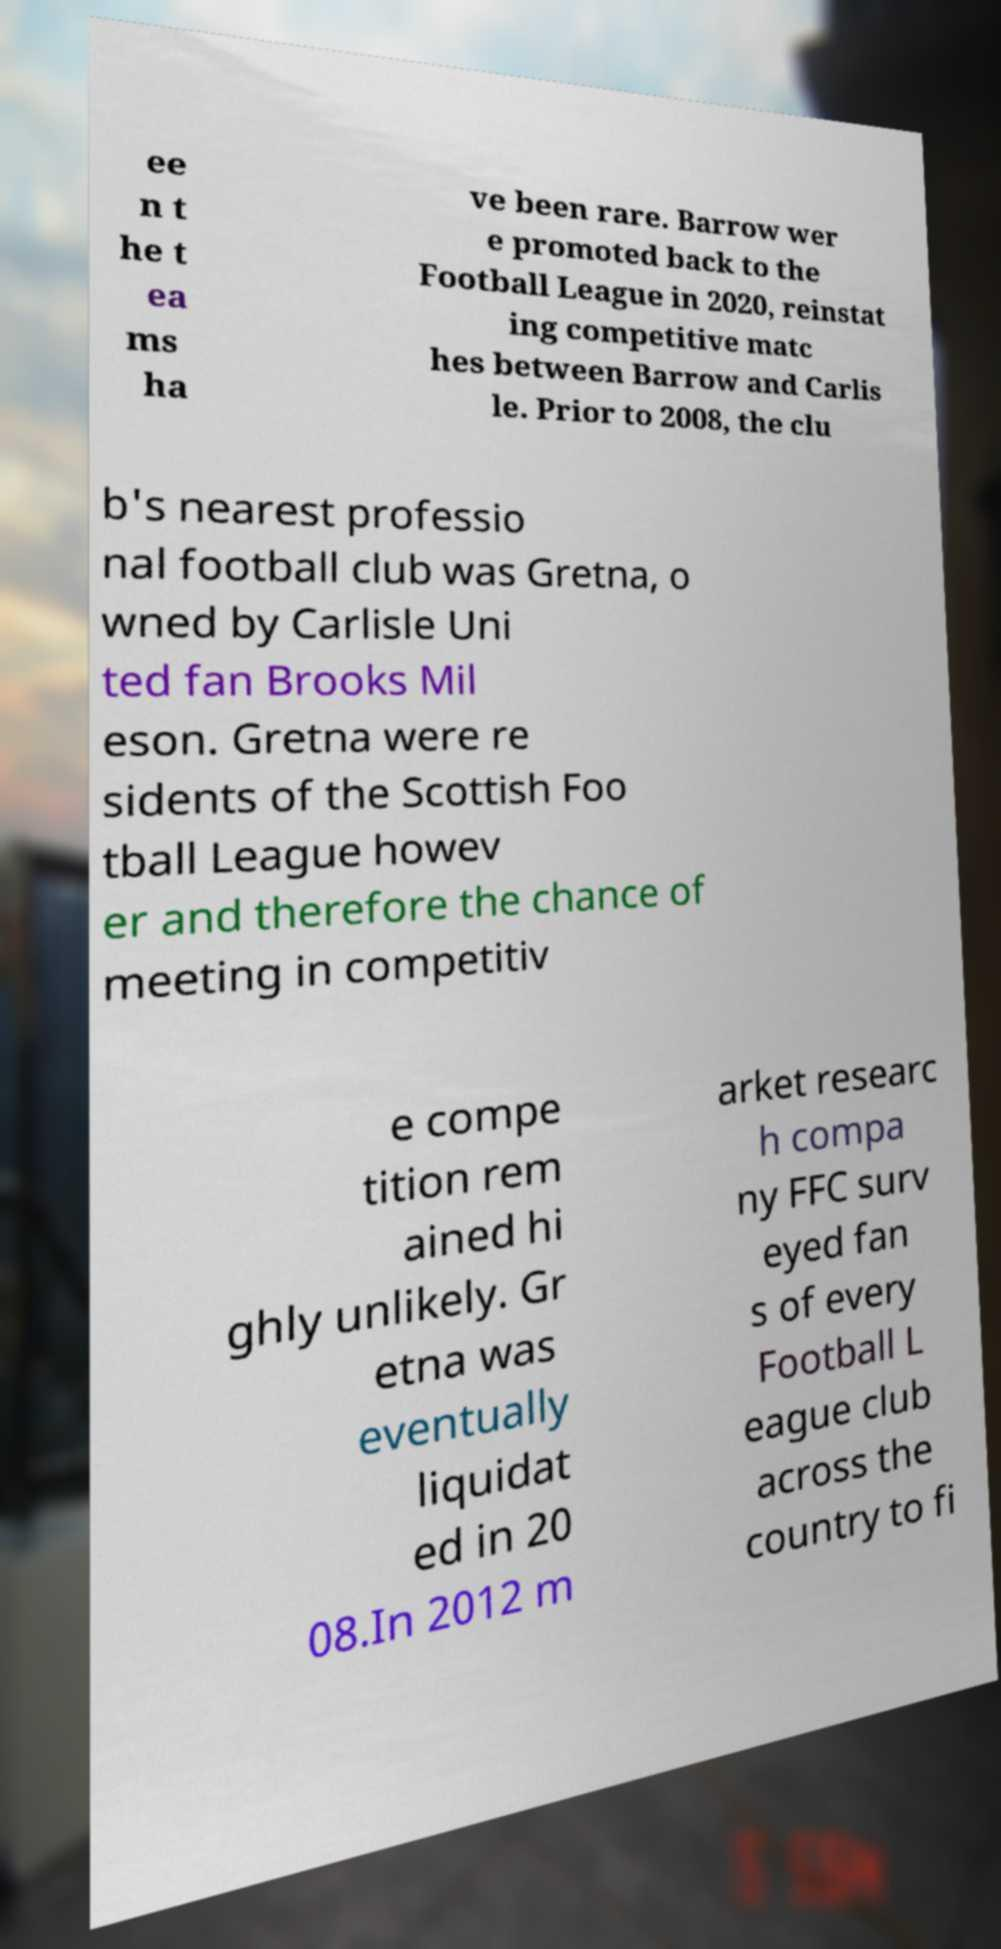Can you accurately transcribe the text from the provided image for me? ee n t he t ea ms ha ve been rare. Barrow wer e promoted back to the Football League in 2020, reinstat ing competitive matc hes between Barrow and Carlis le. Prior to 2008, the clu b's nearest professio nal football club was Gretna, o wned by Carlisle Uni ted fan Brooks Mil eson. Gretna were re sidents of the Scottish Foo tball League howev er and therefore the chance of meeting in competitiv e compe tition rem ained hi ghly unlikely. Gr etna was eventually liquidat ed in 20 08.In 2012 m arket researc h compa ny FFC surv eyed fan s of every Football L eague club across the country to fi 